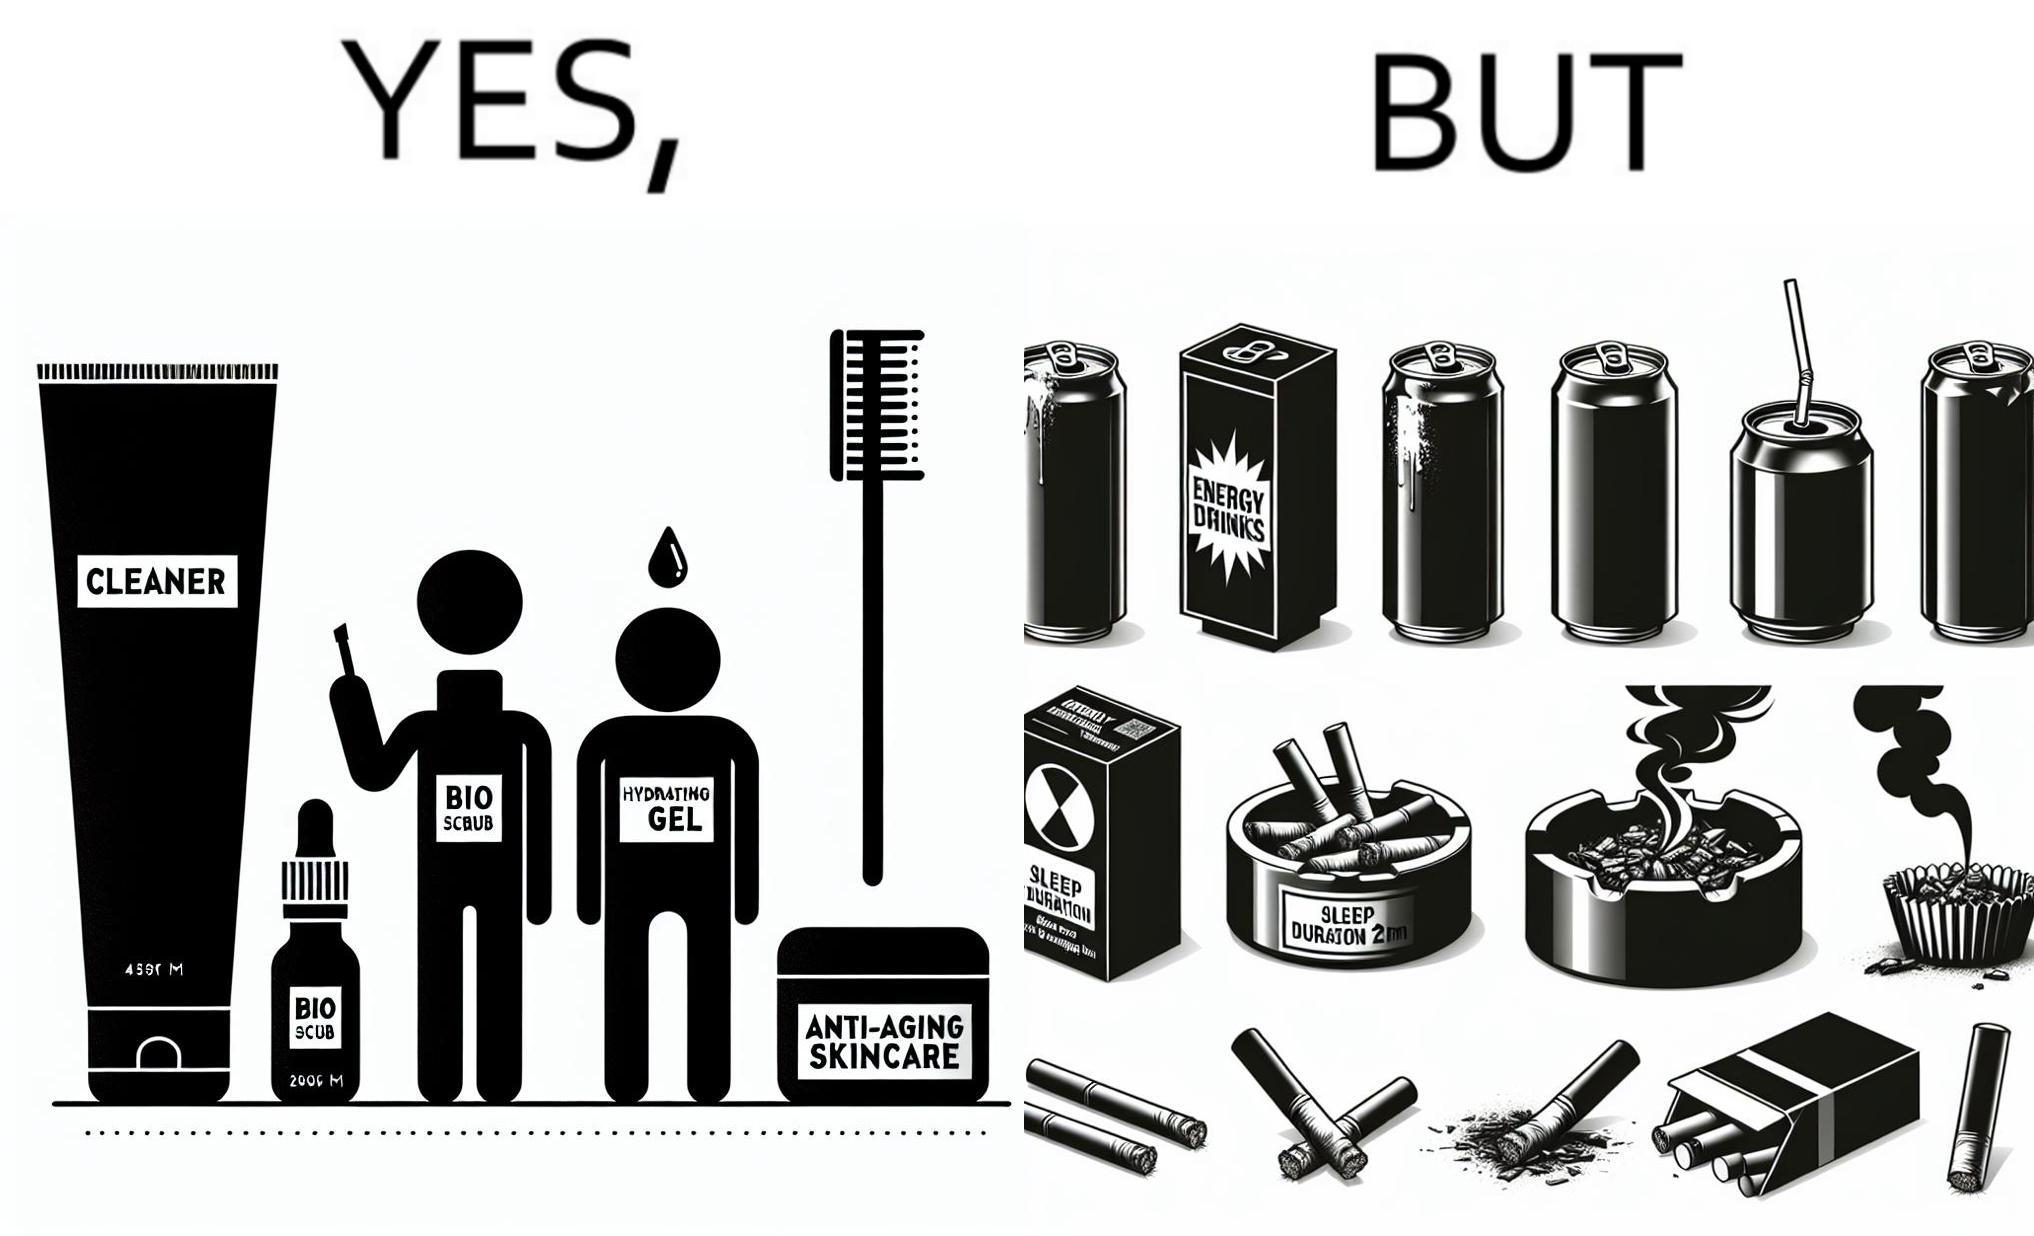What does this image depict? This image is ironic as on the one hand, the presumed person is into skincare and wants to do the best for their skin, which is good, but on the other hand, they are involved in unhealthy habits that will damage their skin like smoking, caffeine and inadequate sleep. 